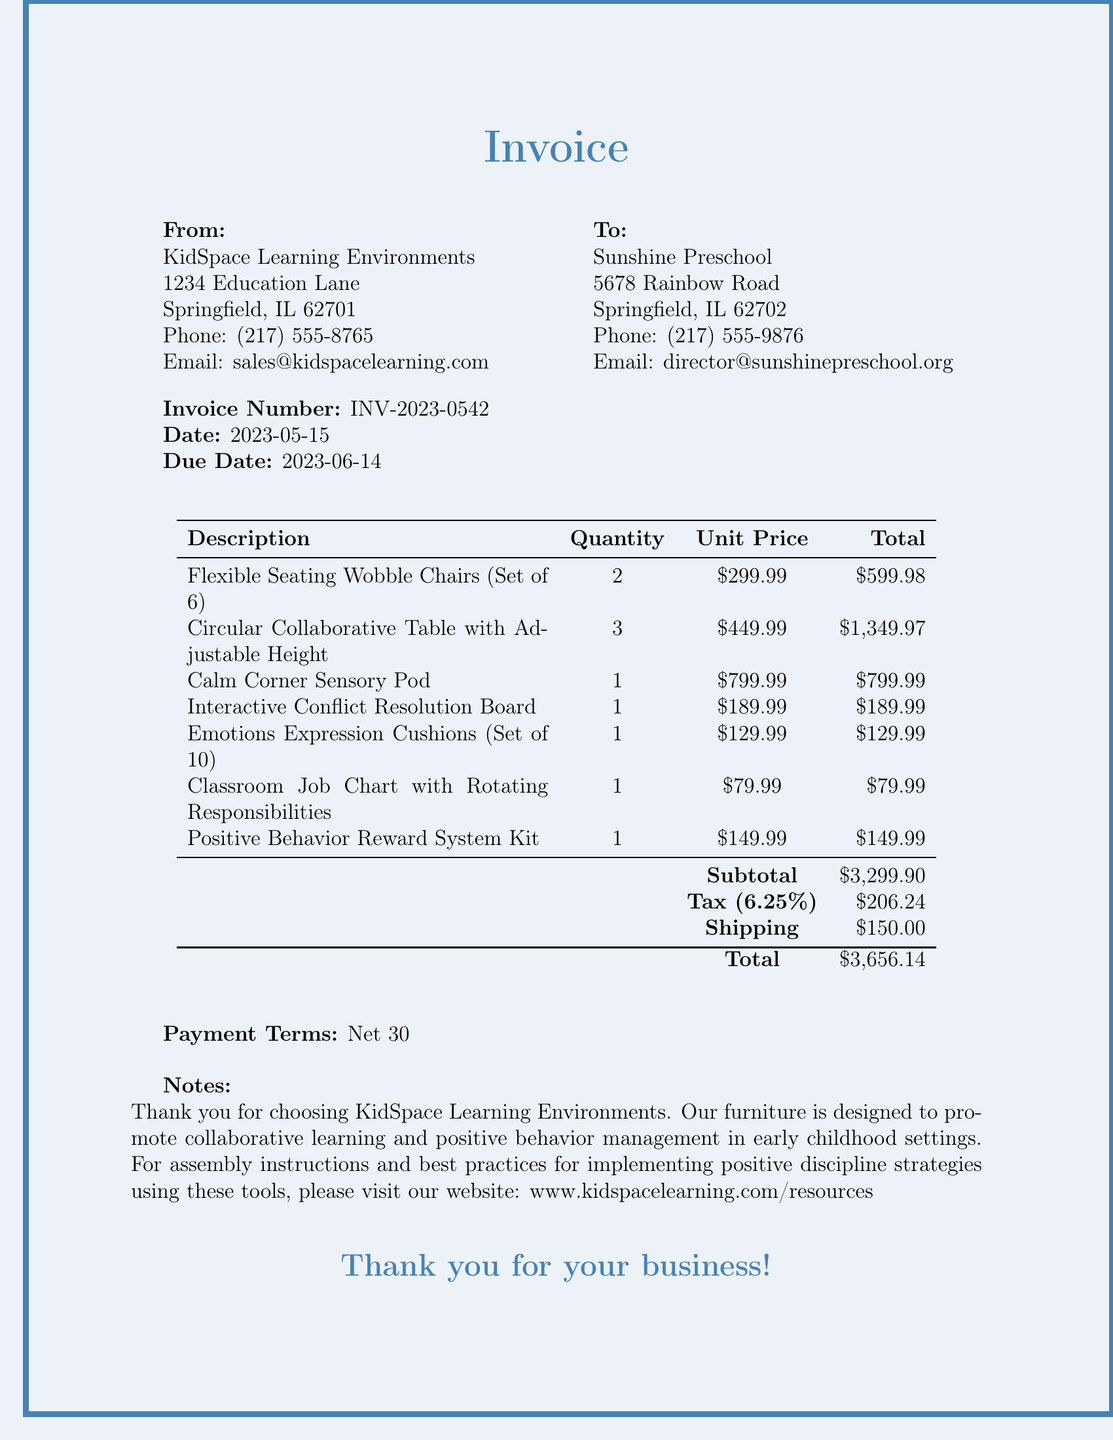What is the invoice number? The invoice number is clearly stated in the document, providing a unique identifier for the transaction.
Answer: INV-2023-0542 What is the due date for this invoice? The due date indicates when the payment for the invoice is expected, and it is specified in the document.
Answer: 2023-06-14 How many Circular Collaborative Tables were purchased? The quantity of each item is listed in the invoice, showing how many of each were ordered.
Answer: 3 What is the total amount billed? The total amount billed includes the subtotal, tax, and shipping costs, which are clearly summarized in the document.
Answer: $3,656.14 Who is the seller of the furniture? The seller's information is detailed at the top of the invoice, providing contact details and their name.
Answer: KidSpace Learning Environments What is the tax rate applied to the invoice? The tax rate is specified in the invoice and is important for calculating the total amount due.
Answer: 6.25% What item promotes conflict resolution? The invoice lists specific items, and one explicitly indicates its purpose related to conflict resolution within the classroom.
Answer: Interactive Conflict Resolution Board What is the payment term for this invoice? The payment terms indicate how long after the invoice date payment should be made, as outlined in the document.
Answer: Net 30 How many Positive Behavior Reward System Kits were ordered? Each item’s quantity is shown in the invoice, detailing how many kits were included in the order.
Answer: 1 